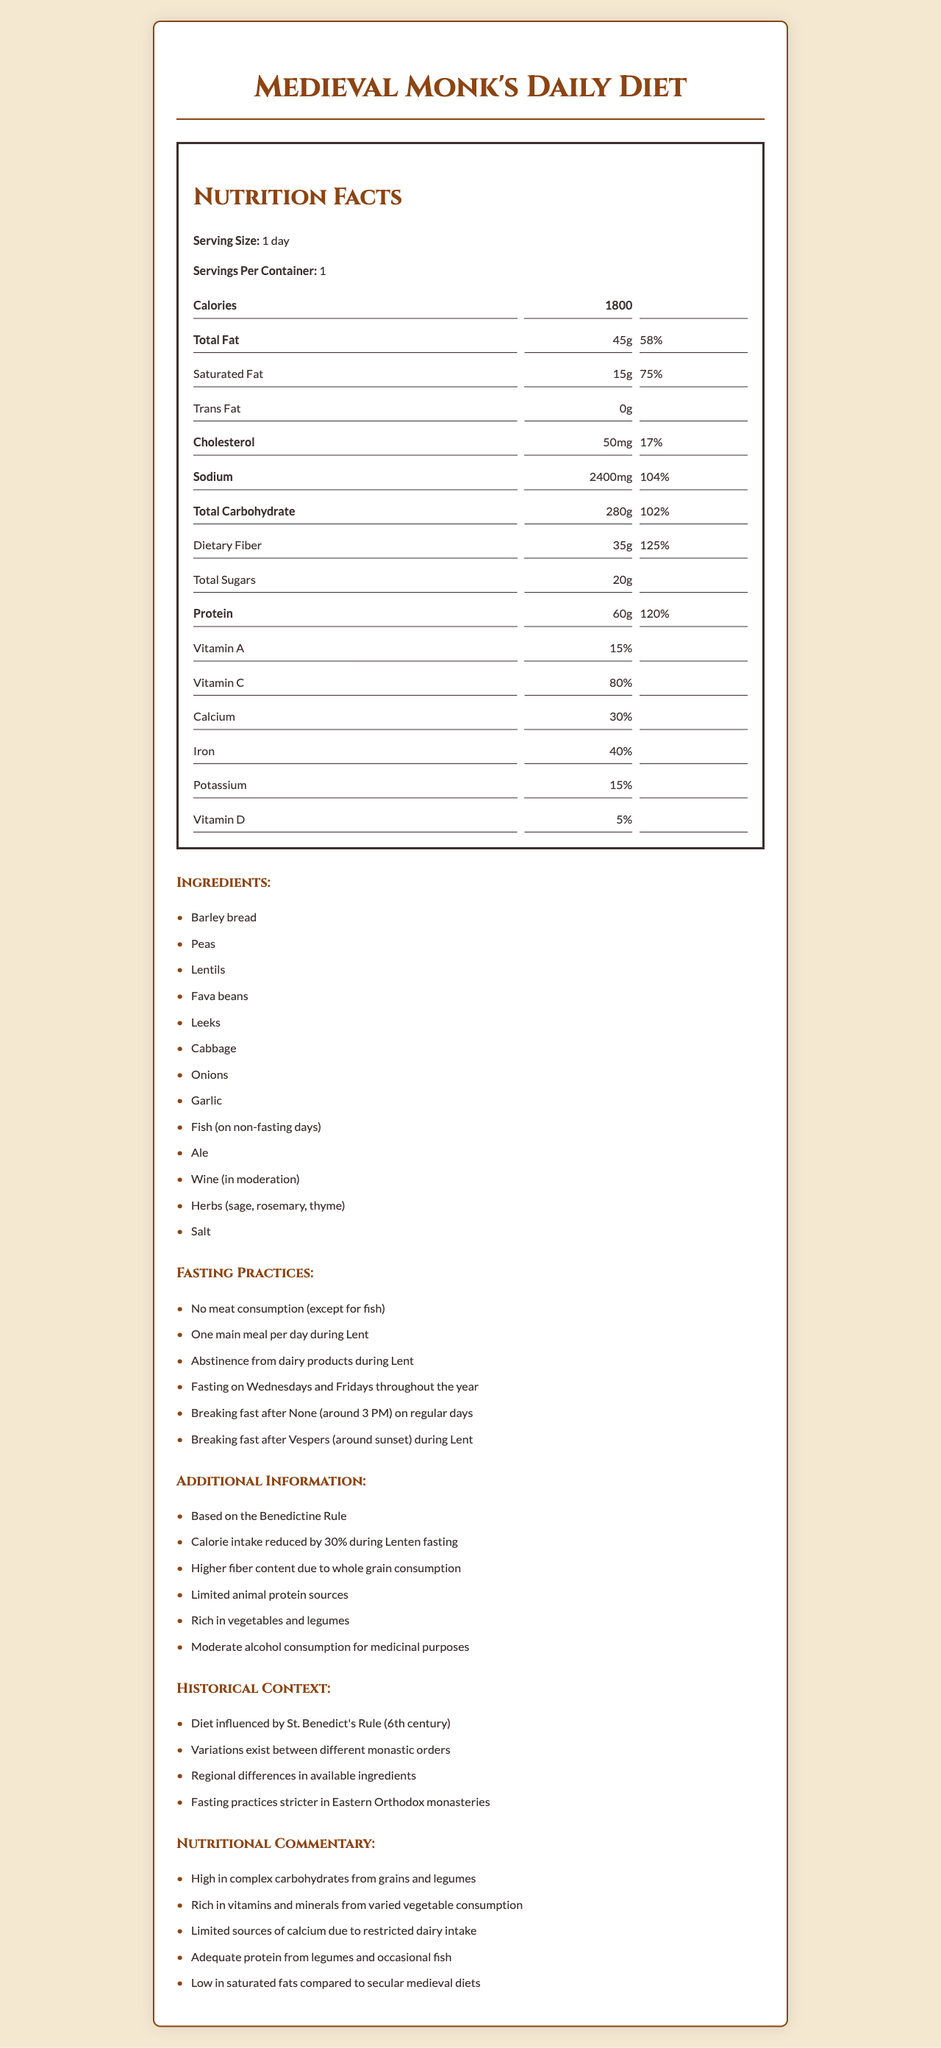how many calories in a monk's daily diet? The document specifies that the daily diet of a medieval monk contains 1800 calories.
Answer: 1800 calories what is the daily value percentage of total fat? The document indicates that the daily value percentage for total fat is 58%.
Answer: 58% what is the serving size of the diet? The serving size mentioned in the document is 1 day.
Answer: 1 day which ingredient is consumed only on non-fasting days? According to the ingredients list in the document, fish is consumed on non-fasting days only.
Answer: Fish on which days do monks fast throughout the year? The document states that monks fast on Wednesdays and Fridays throughout the year.
Answer: Wednesdays and Fridays what is the primary source of protein in this diet? The document lists legumes (peas, lentils, fava beans) and occasional fish as sources of protein.
Answer: Legumes and occasional fish what is the cholesterol daily value percentage? It is stated that the daily value for cholesterol is 17%.
Answer: 17% how is the diet influenced? The historical context section mentions that the diet is influenced by St. Benedict’s Rule from the 6th century.
Answer: By St. Benedict's Rule (6th century) Which of the following is a common fasting practice in the monastery? 
A. Consumption of meat 
B. One main meal per day during Lent 
C. Extensive use of dairy products The document lists "One main meal per day during Lent" as a fasting practice, while meat consumption and dairy products are restricted.
Answer: B Which nutrient is highest in daily value percentage? 
1. Fiber 
2. Protein 
3. Vitamin C 
4. Sodium The document shows that dietary fiber has the highest daily value percentage at 125%.
Answer: 1 is alcohol consumption allowed in this diet? The document mentions moderate consumption of ale and wine for medicinal purposes.
Answer: Yes summarize the main idea of the document. The summary of the document covers its purpose, key elements of the diet including its nutritional breakdown, fasting rules, and historical influence.
Answer: The document provides detailed nutritional information about a medieval monk's daily diet, which is influenced by the Benedictine Rule. It includes details of the typical ingredients, fasting practices, additional dietary information, historical context, and a nutritional commentary. The diet is notably high in complex carbohydrates and fiber, has a restricted intake of meat and dairy, and follows specific fasting rules. what is the exact percentage of daily vitamin D intake in the diet? The document specifies that vitamin D contributes to 5% of the daily value.
Answer: 5% how does the calorie intake change during Lenten fasting? The document states that the calorie intake is reduced by 30% during Lenten fasting.
Answer: Reduced by 30% how many ingredients are listed in the diet? The document lists 13 ingredients in the medieval monk's daily diet.
Answer: 13 what are the regional differences mentioned in the context? The document mentions that there are regional differences in available ingredients, but does not specify what those differences are.
Answer: Cannot be determined 